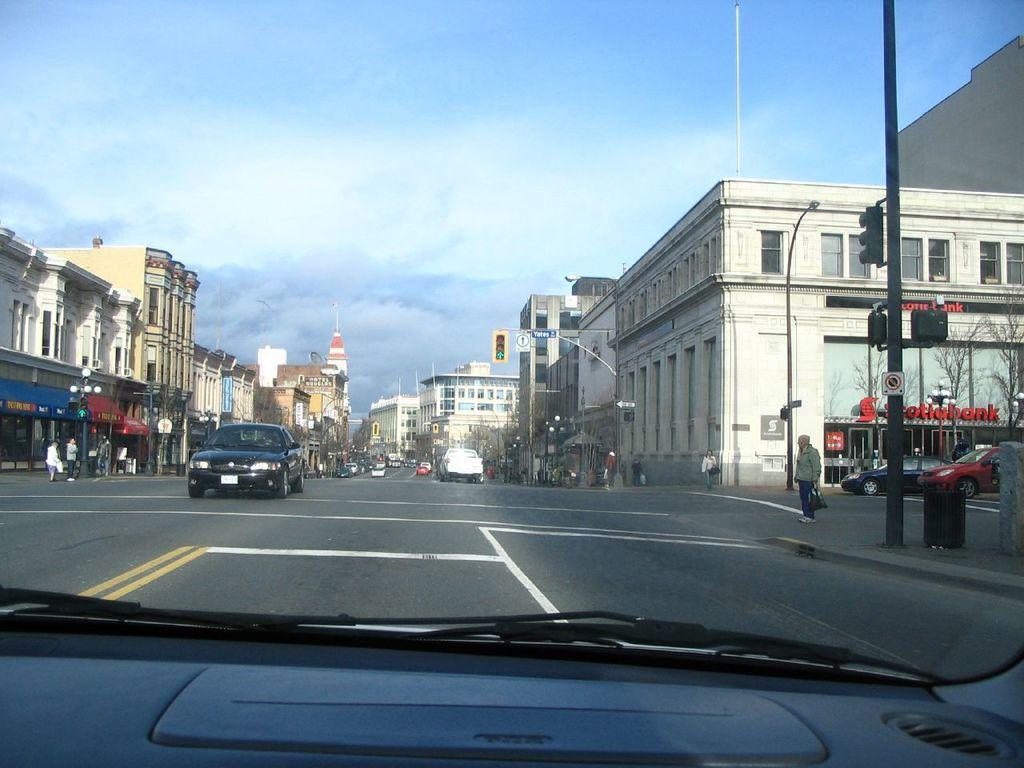How would you summarize this image in a sentence or two? In this image I can see few vehicles on the road, background I can see few persons standing, few light poles, few stalls, buildings in cream, white and brown color and the sky is in blue and white color. 